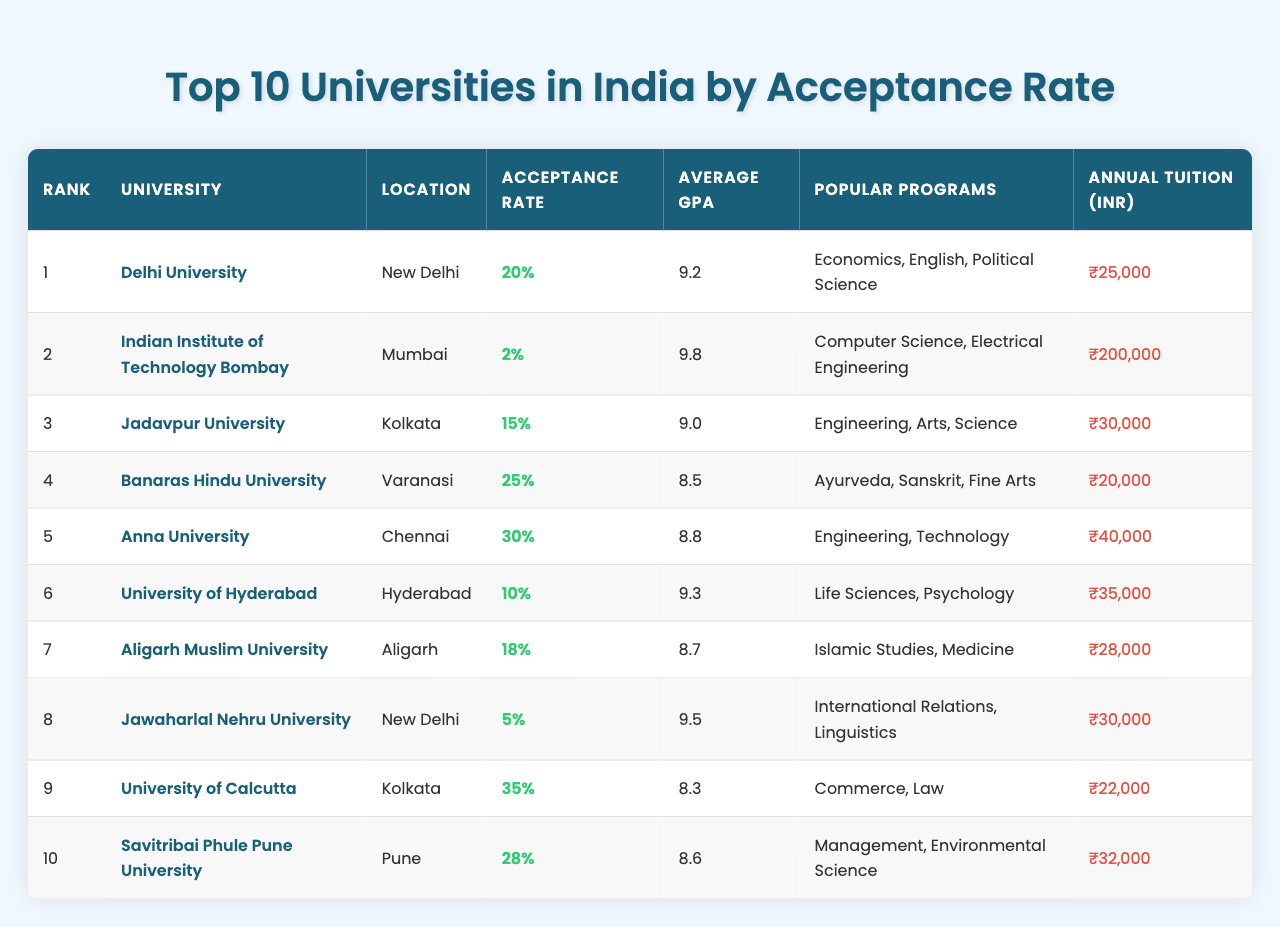What is the acceptance rate for Delhi University? The acceptance rate for Delhi University is listed directly in the table under the "Acceptance Rate" column, which shows 20%.
Answer: 20% Which university has the highest acceptance rate? In the table, the university with the highest acceptance rate is University of Calcutta at 35%.
Answer: University of Calcutta What is the average GPA of Indian Institute of Technology Bombay? The average GPA for Indian Institute of Technology Bombay, as shown in the table, is 9.8, which is found in the "Average GPA" column.
Answer: 9.8 Is the annual tuition fee for Banaras Hindu University higher than that for Anna University? The table indicates that Banaras Hindu University's tuition is ₹20,000, while Anna University's is ₹40,000. Since ₹20,000 is less than ₹40,000, the statement is false.
Answer: No What is the difference in acceptance rates between Jawaharlal Nehru University and Aligarh Muslim University? Jawaharlal Nehru University has an acceptance rate of 5%, and Aligarh Muslim University has 18%. The difference is 18% - 5% = 13%.
Answer: 13% How many universities have an acceptance rate of less than 15%? In the table, from the data, we find that there are three universities with acceptance rates below 15%: IIT Bombay (2%), University of Hyderabad (10%), and Jawaharlal Nehru University (5%).
Answer: 3 What is the total annual tuition cost for the top three universities based on acceptance rate? The annual tuition for the top three universities is ₹25,000 (Delhi University) + ₹200,000 (IIT Bombay) + ₹30,000 (Jadavpur University) = ₹255,000.
Answer: ₹255,000 Which university is located in Hyderabad, and what is its acceptance rate? Referring to the table, University of Hyderabad is indicated as being located in Hyderabad, with an acceptance rate of 10%.
Answer: University of Hyderabad, 10% If you wanted to study Arts, which universities listed would you consider? The table shows that Jadavpur University (Arts) and Banaras Hindu University (Fine Arts) are noted for their Arts programs.
Answer: Jadavpur University, Banaras Hindu University What is the average acceptance rate of the universities listed in the table? To find the average acceptance rate, we convert acceptance rates to decimals: (0.20 + 0.02 + 0.15 + 0.25 + 0.30 + 0.10 + 0.18 + 0.05 + 0.35 + 0.28) / 10 = 0.175 or 17.5%.
Answer: 17.5% 